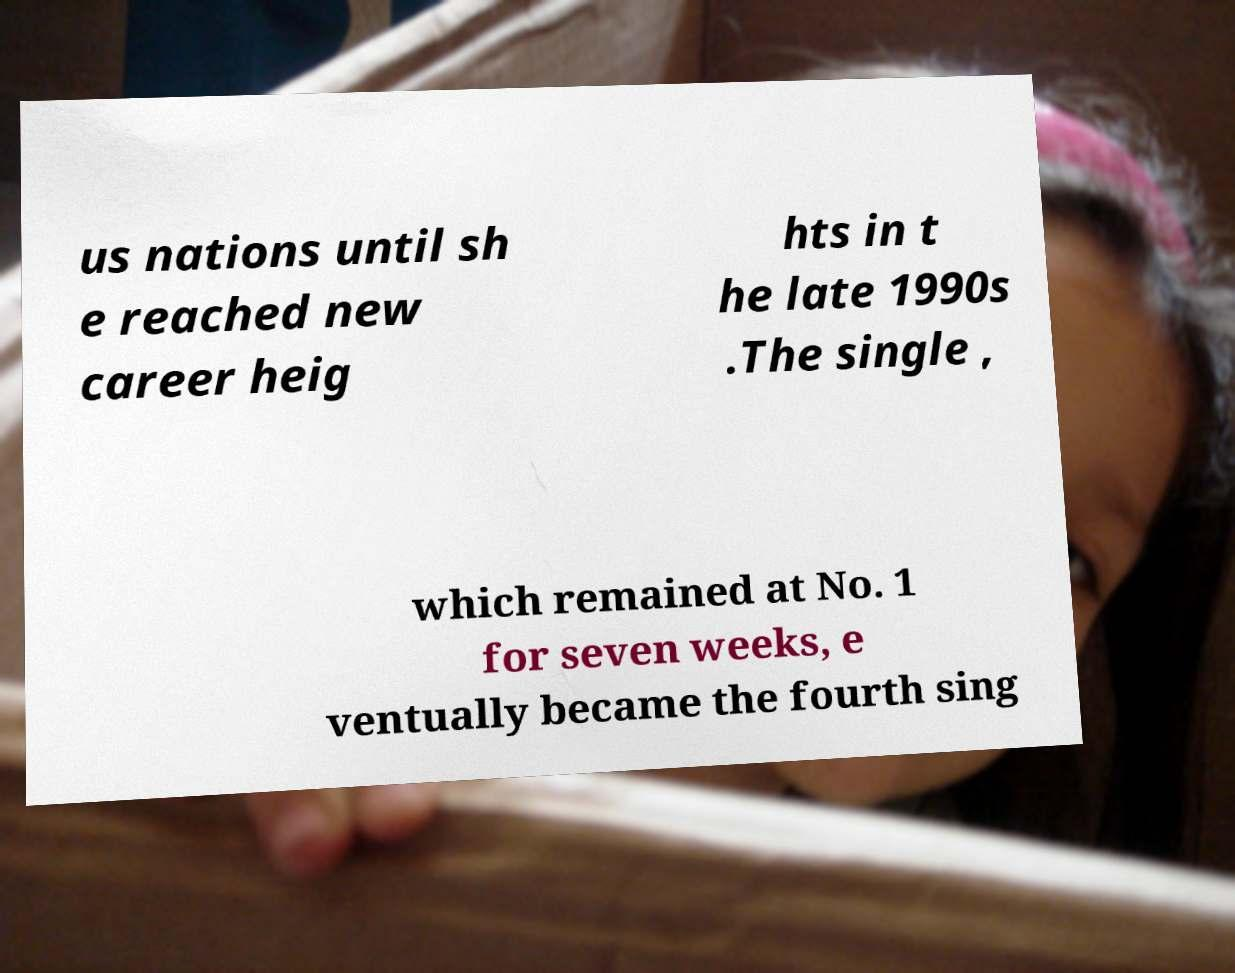There's text embedded in this image that I need extracted. Can you transcribe it verbatim? us nations until sh e reached new career heig hts in t he late 1990s .The single , which remained at No. 1 for seven weeks, e ventually became the fourth sing 